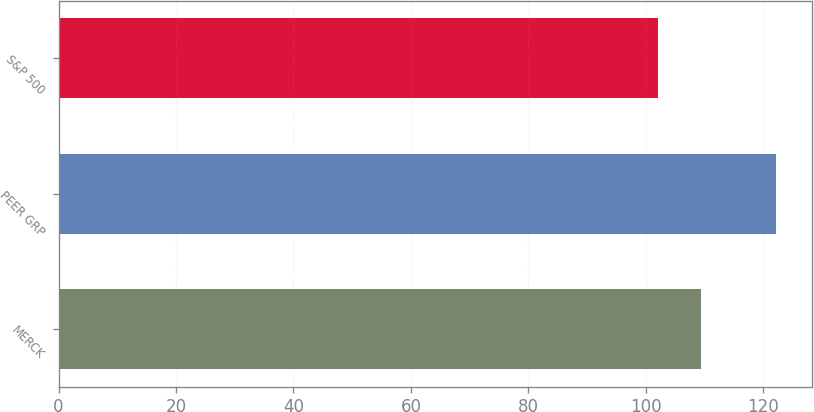<chart> <loc_0><loc_0><loc_500><loc_500><bar_chart><fcel>MERCK<fcel>PEER GRP<fcel>S&P 500<nl><fcel>109.4<fcel>122.23<fcel>102.1<nl></chart> 